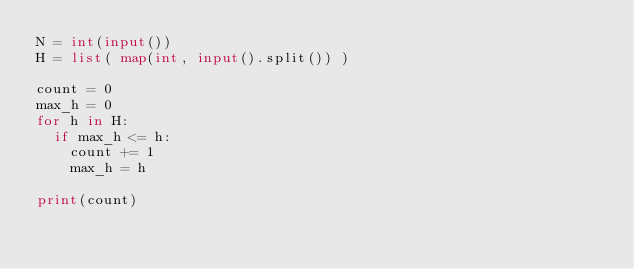Convert code to text. <code><loc_0><loc_0><loc_500><loc_500><_Python_>N = int(input())
H = list( map(int, input().split()) )

count = 0
max_h = 0
for h in H:
  if max_h <= h:
    count += 1
    max_h = h

print(count)</code> 